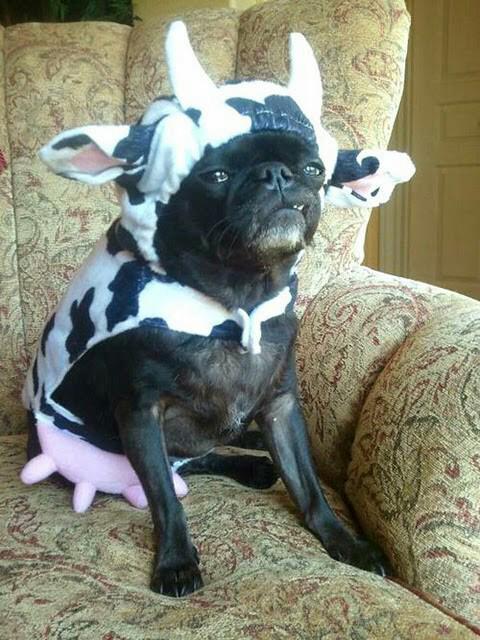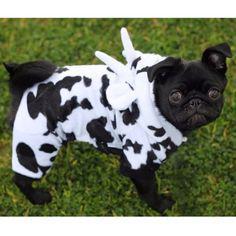The first image is the image on the left, the second image is the image on the right. Evaluate the accuracy of this statement regarding the images: "All of the animals are enclosed in the field.". Is it true? Answer yes or no. No. The first image is the image on the left, the second image is the image on the right. Given the left and right images, does the statement "Images show a total of two pugs dressed in black and white cow costumes." hold true? Answer yes or no. Yes. 